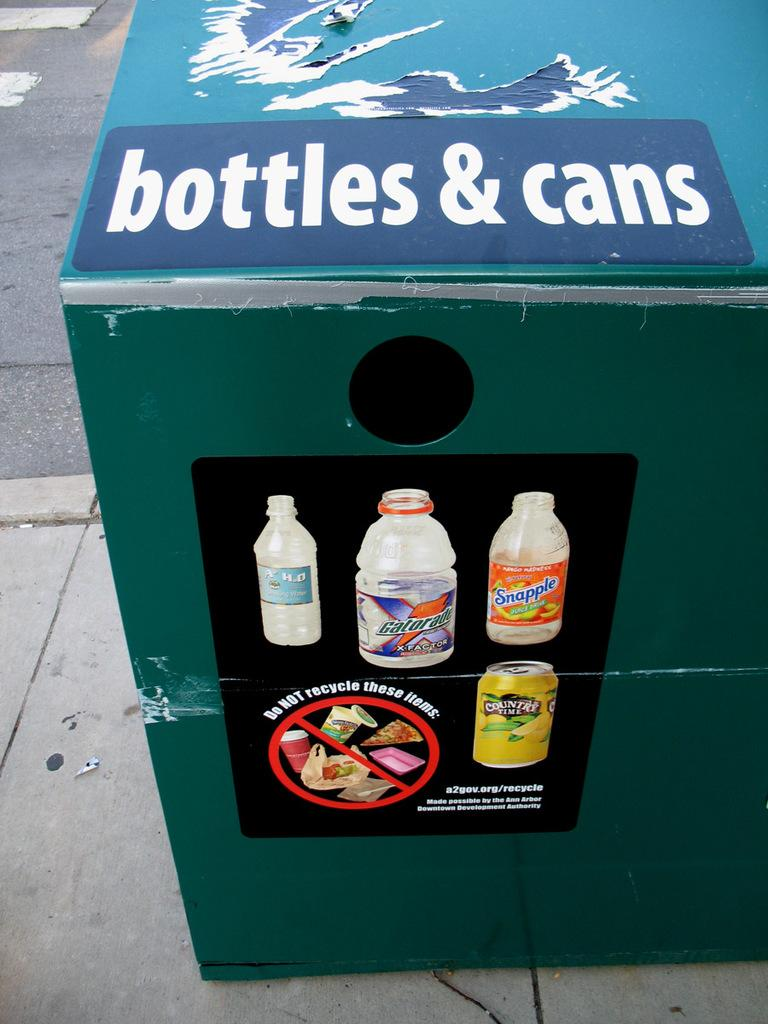<image>
Provide a brief description of the given image. A recycling box that has the words bottles and cans on it. 